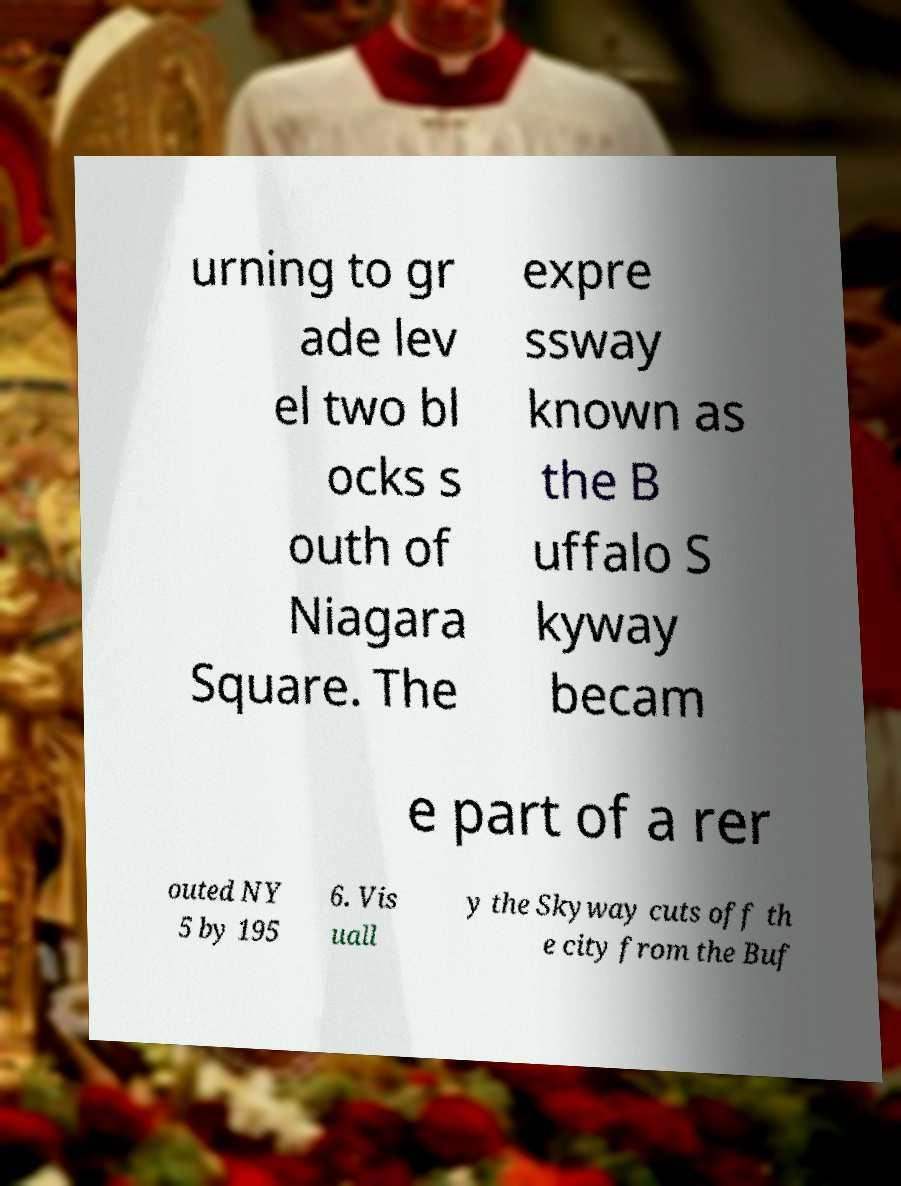Could you assist in decoding the text presented in this image and type it out clearly? urning to gr ade lev el two bl ocks s outh of Niagara Square. The expre ssway known as the B uffalo S kyway becam e part of a rer outed NY 5 by 195 6. Vis uall y the Skyway cuts off th e city from the Buf 